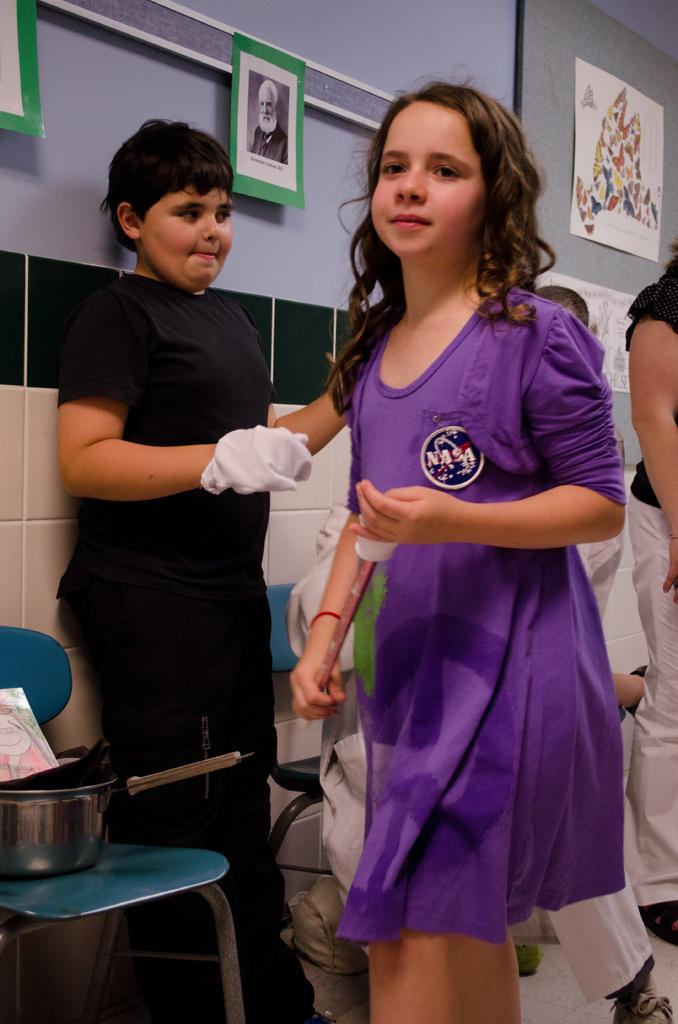Who or what can be seen in the image? There are people in the image. What is located on the left side of the image? There are objects on a chair on the left side of the image. What can be seen in the background of the image? There are pictures on the wall in the background of the image. Where is the nearest park to the location depicted in the image? The image does not provide any information about the location or the presence of a park, so it cannot be determined from the image. 